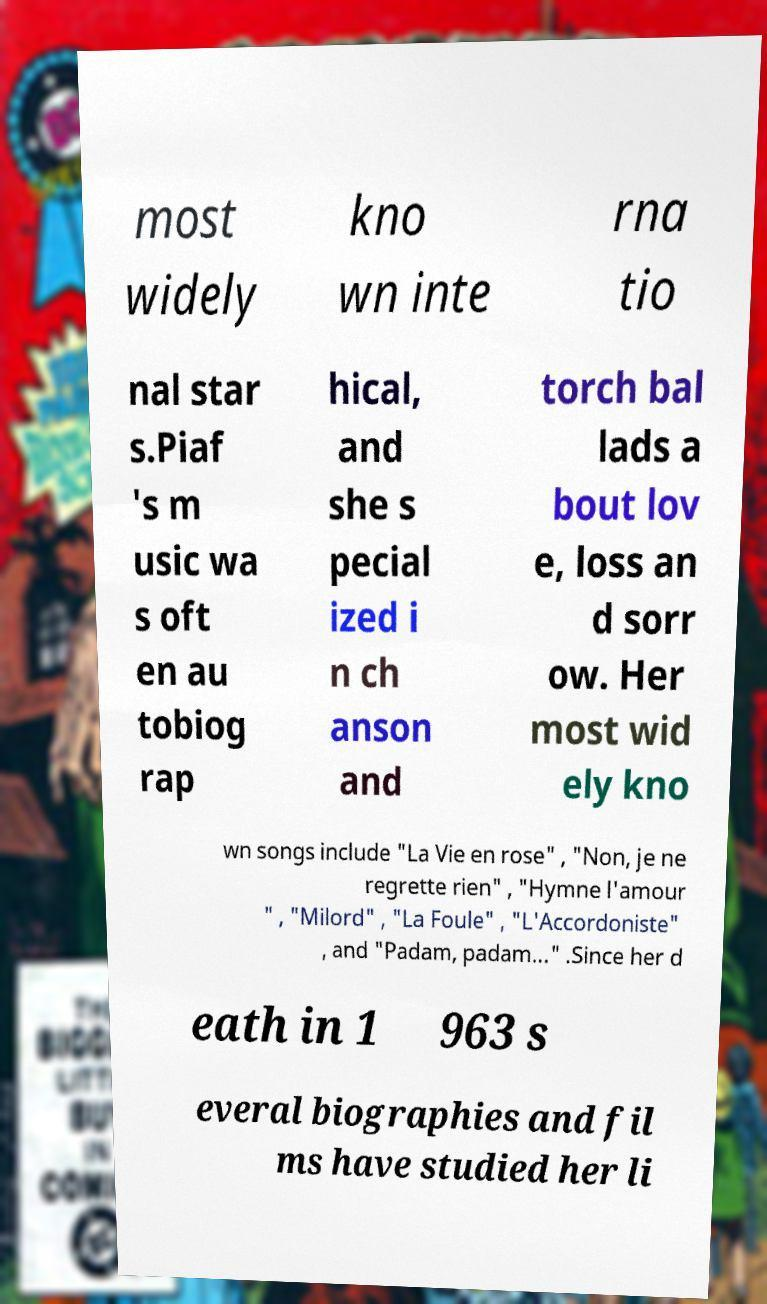There's text embedded in this image that I need extracted. Can you transcribe it verbatim? most widely kno wn inte rna tio nal star s.Piaf 's m usic wa s oft en au tobiog rap hical, and she s pecial ized i n ch anson and torch bal lads a bout lov e, loss an d sorr ow. Her most wid ely kno wn songs include "La Vie en rose" , "Non, je ne regrette rien" , "Hymne l'amour " , "Milord" , "La Foule" , "L'Accordoniste" , and "Padam, padam..." .Since her d eath in 1 963 s everal biographies and fil ms have studied her li 